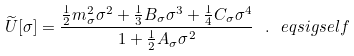<formula> <loc_0><loc_0><loc_500><loc_500>\widetilde { U } [ \sigma ] = \frac { \frac { 1 } { 2 } { m _ { \sigma } ^ { 2 } } \sigma ^ { 2 } + \frac { 1 } { 3 } B _ { \sigma } \sigma ^ { 3 } + \frac { 1 } { 4 } C _ { \sigma } \sigma ^ { 4 } } { 1 + \frac { 1 } { 2 } A _ { \sigma } \sigma ^ { 2 } } \ . \ e q { s i g s e l f }</formula> 